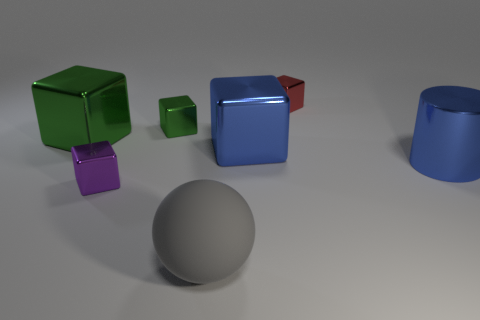What number of cylinders are either blue things or green objects?
Your response must be concise. 1. There is a blue metal object that is to the left of the tiny red cube; is its shape the same as the tiny green metallic object?
Your response must be concise. Yes. What color is the large sphere?
Your response must be concise. Gray. What is the color of the other big metallic object that is the same shape as the large green shiny object?
Offer a very short reply. Blue. What number of green objects have the same shape as the red thing?
Your response must be concise. 2. How many things are big yellow blocks or small objects that are to the right of the gray rubber sphere?
Offer a terse response. 1. There is a rubber object; does it have the same color as the large metallic object behind the large blue cube?
Your response must be concise. No. There is a object that is both in front of the large green shiny cube and behind the shiny cylinder; how big is it?
Your response must be concise. Large. Are there any big blue cylinders to the left of the big green cube?
Your answer should be very brief. No. Are there any large blue objects that are to the left of the blue metal object to the right of the red thing?
Your answer should be compact. Yes. 